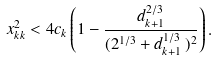Convert formula to latex. <formula><loc_0><loc_0><loc_500><loc_500>x _ { k k } ^ { 2 } < 4 c _ { k } \left ( 1 - \frac { d _ { k + 1 } ^ { 2 / 3 } } { ( 2 ^ { 1 / 3 } + d _ { k + 1 } ^ { 1 / 3 } \, ) ^ { 2 } } \right ) .</formula> 